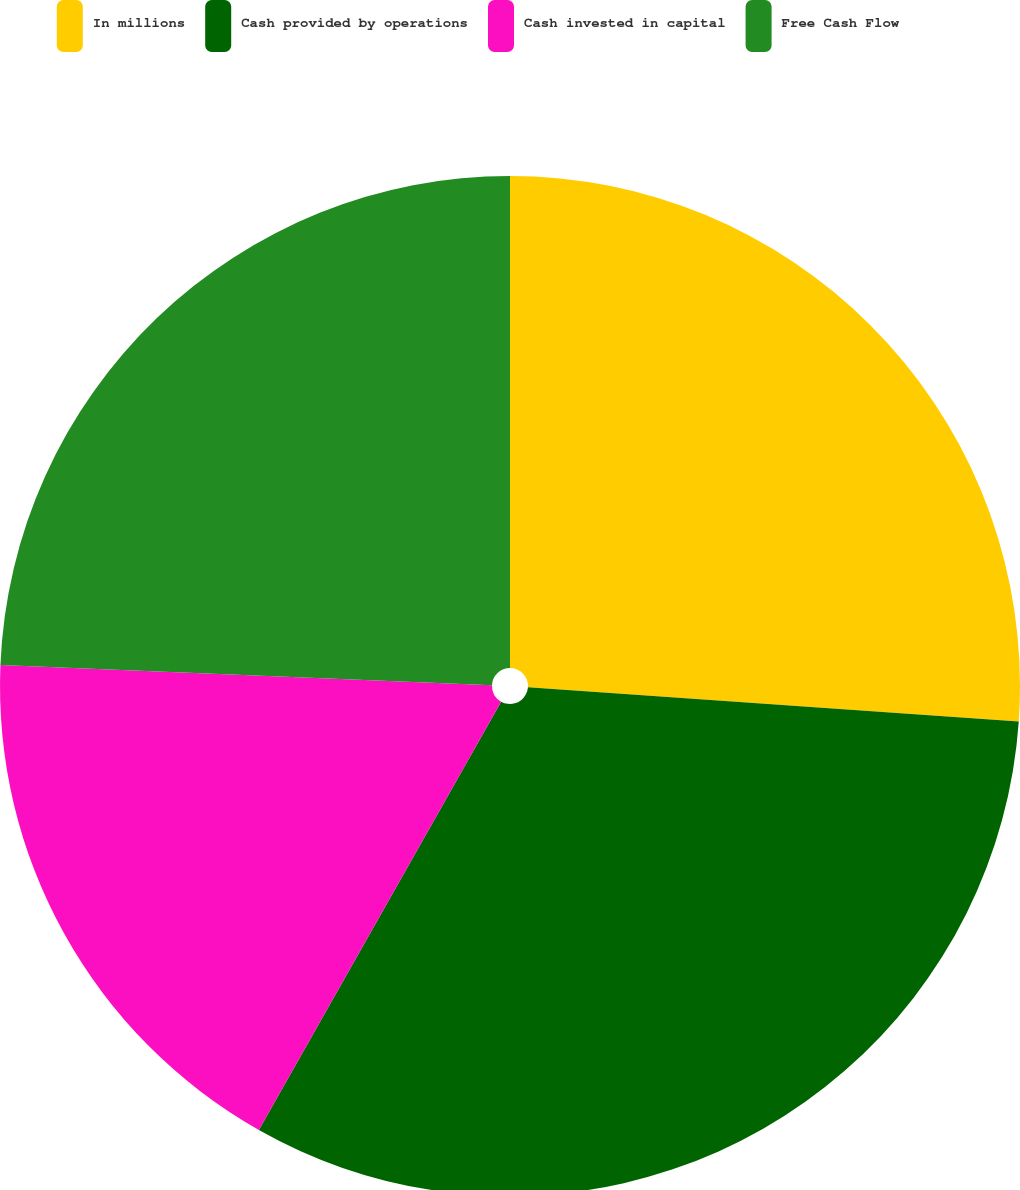Convert chart to OTSL. <chart><loc_0><loc_0><loc_500><loc_500><pie_chart><fcel>In millions<fcel>Cash provided by operations<fcel>Cash invested in capital<fcel>Free Cash Flow<nl><fcel>26.11%<fcel>32.09%<fcel>17.46%<fcel>24.35%<nl></chart> 